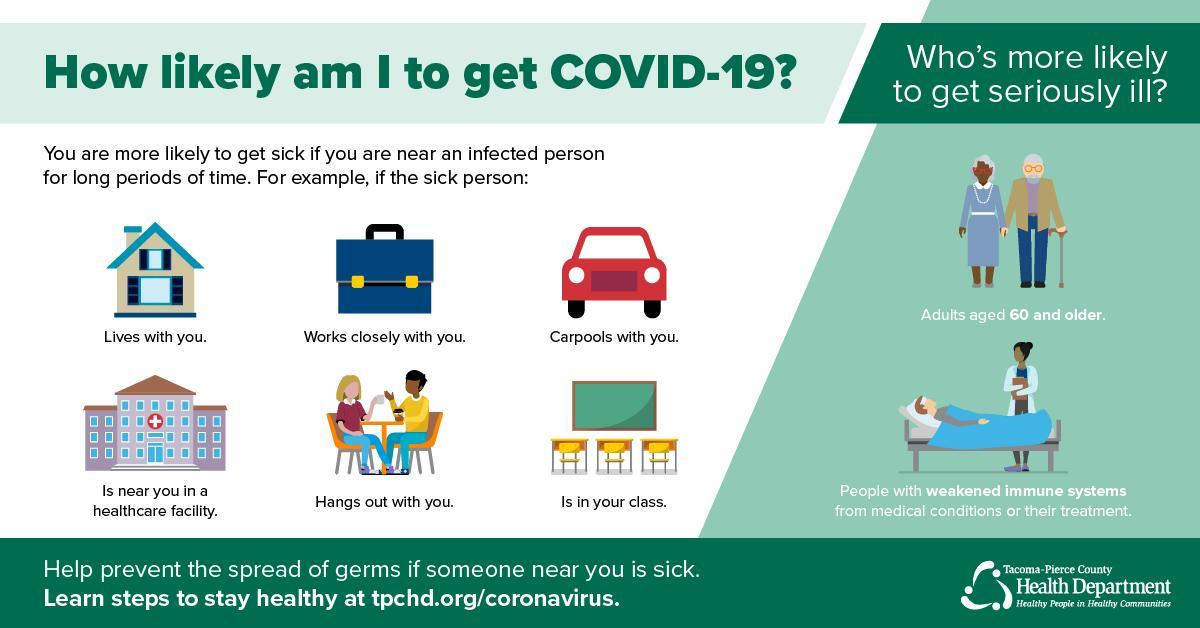What is the fifth way to get sick if we are near an infected person?
Answer the question with a short phrase. Hangs out with you What is the third way to get sick if we are near an infected person? Carpools with you 